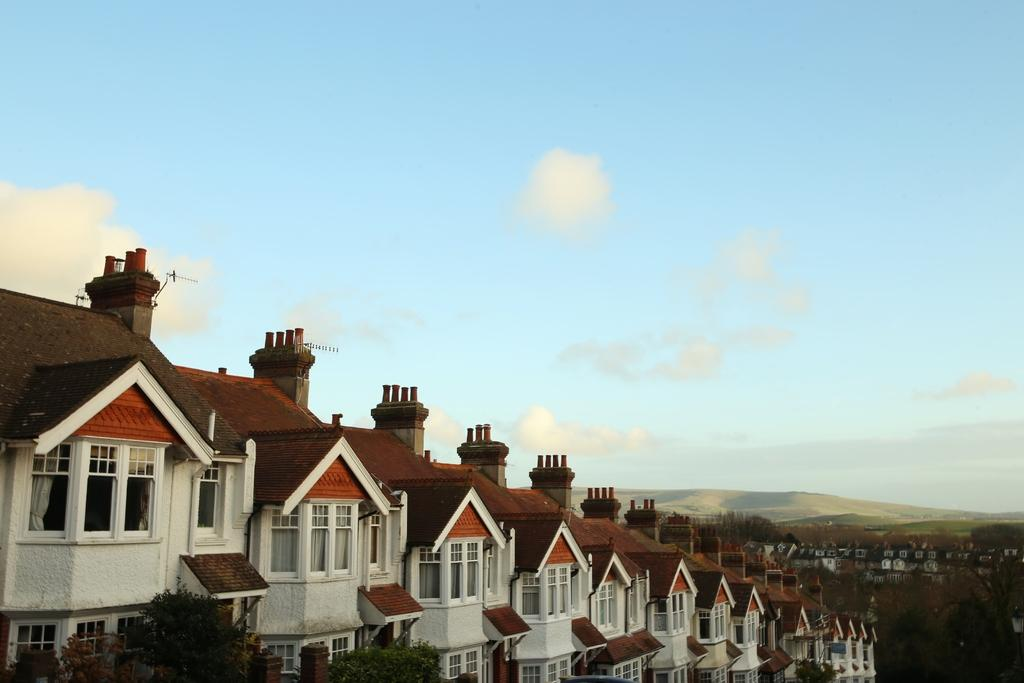What type of structures can be seen in the image? There are buildings in the image. What type of natural elements can be seen in the image? There are trees and mountains in the image. What part of the natural environment is visible in the image? The sky is visible in the image. What type of body is visible in the image? There is no body present in the image; it features buildings, trees, mountains, and the sky. 